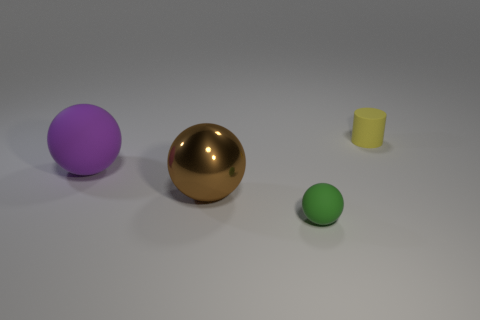What can you infer about the lighting in the scene? The scene seems to be uniformly lit with diffuse, soft lighting, as indicated by the subtle shadows under the objects, suggesting an overcast sky or a studio setting with diffused light sources. 